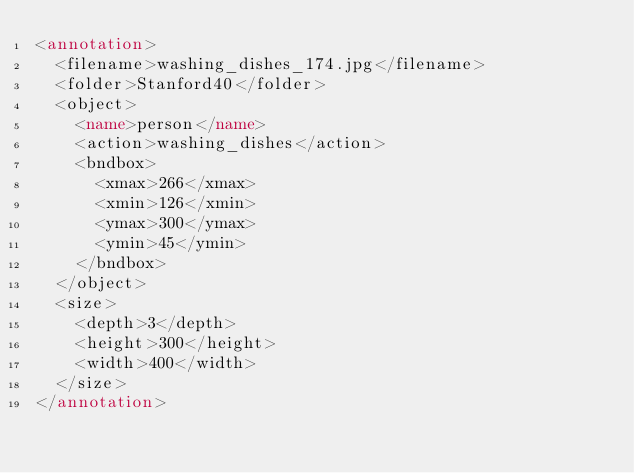Convert code to text. <code><loc_0><loc_0><loc_500><loc_500><_XML_><annotation>
  <filename>washing_dishes_174.jpg</filename>
  <folder>Stanford40</folder>
  <object>
    <name>person</name>
    <action>washing_dishes</action>
    <bndbox>
      <xmax>266</xmax>
      <xmin>126</xmin>
      <ymax>300</ymax>
      <ymin>45</ymin>
    </bndbox>
  </object>
  <size>
    <depth>3</depth>
    <height>300</height>
    <width>400</width>
  </size>
</annotation>
</code> 